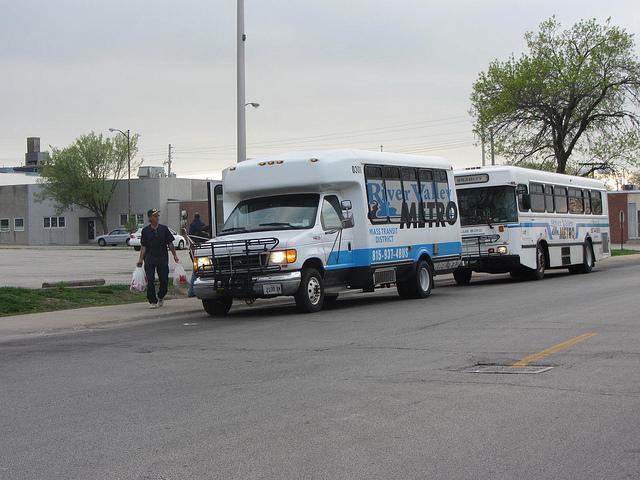What did the man on the sidewalk most likely just do?
Select the correct answer and articulate reasoning with the following format: 'Answer: answer
Rationale: rationale.'
Options: Shop, shower, steal, exercise. Answer: shop.
Rationale: He is holding two grocery bags so he probably just bought food. 